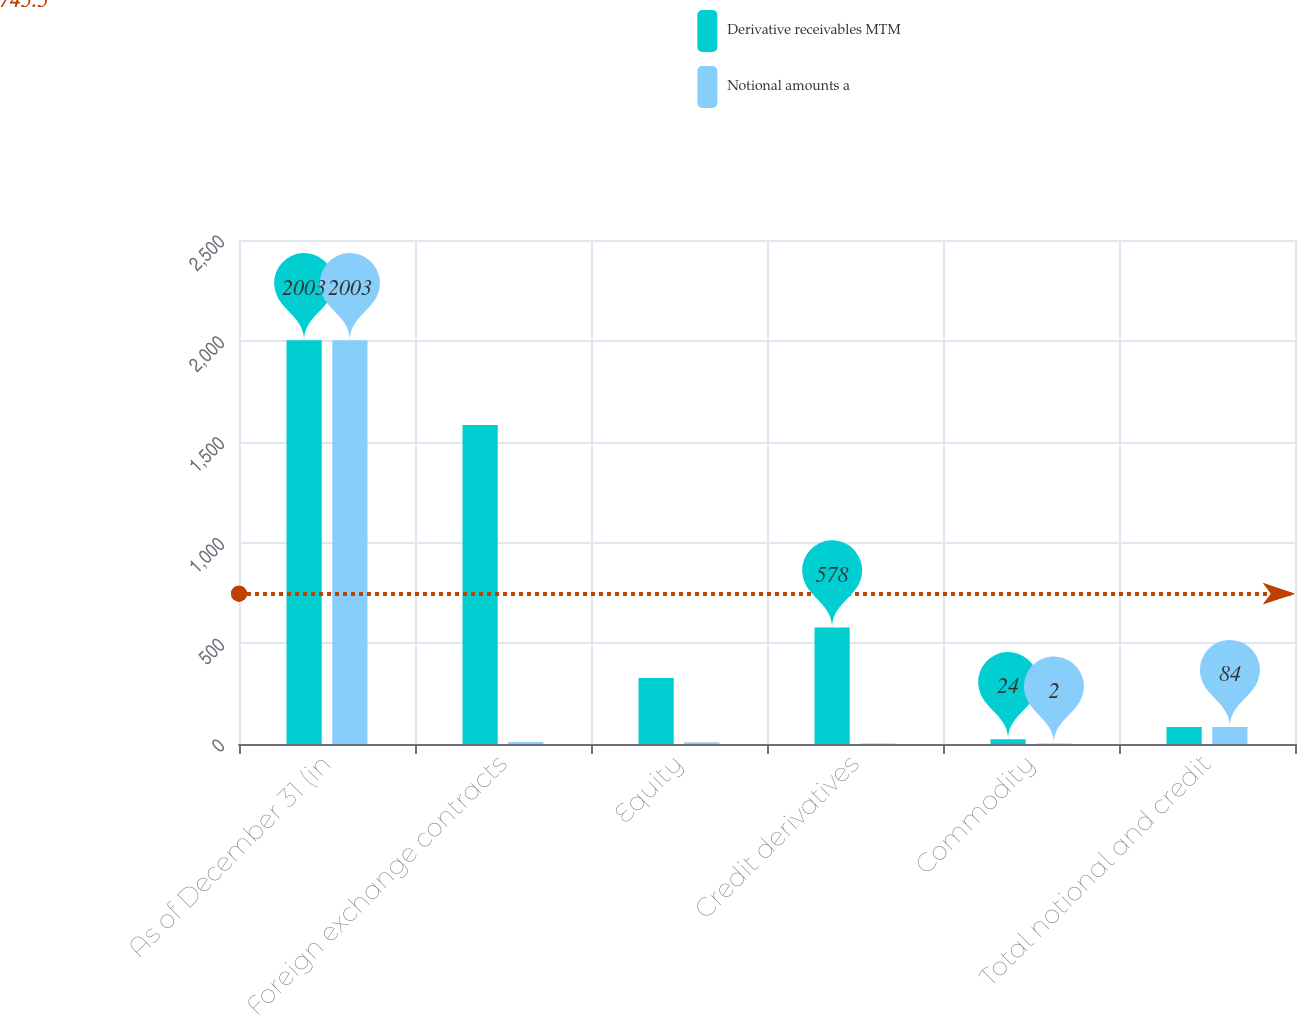<chart> <loc_0><loc_0><loc_500><loc_500><stacked_bar_chart><ecel><fcel>As of December 31 (in<fcel>Foreign exchange contracts<fcel>Equity<fcel>Credit derivatives<fcel>Commodity<fcel>Total notional and credit<nl><fcel>Derivative receivables MTM<fcel>2003<fcel>1582<fcel>328<fcel>578<fcel>24<fcel>84<nl><fcel>Notional amounts a<fcel>2003<fcel>10<fcel>9<fcel>3<fcel>2<fcel>84<nl></chart> 